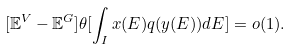Convert formula to latex. <formula><loc_0><loc_0><loc_500><loc_500>[ \mathbb { E } ^ { V } - \mathbb { E } ^ { G } ] \theta [ \int _ { I } x ( E ) q ( y ( E ) ) d E ] = o ( 1 ) .</formula> 